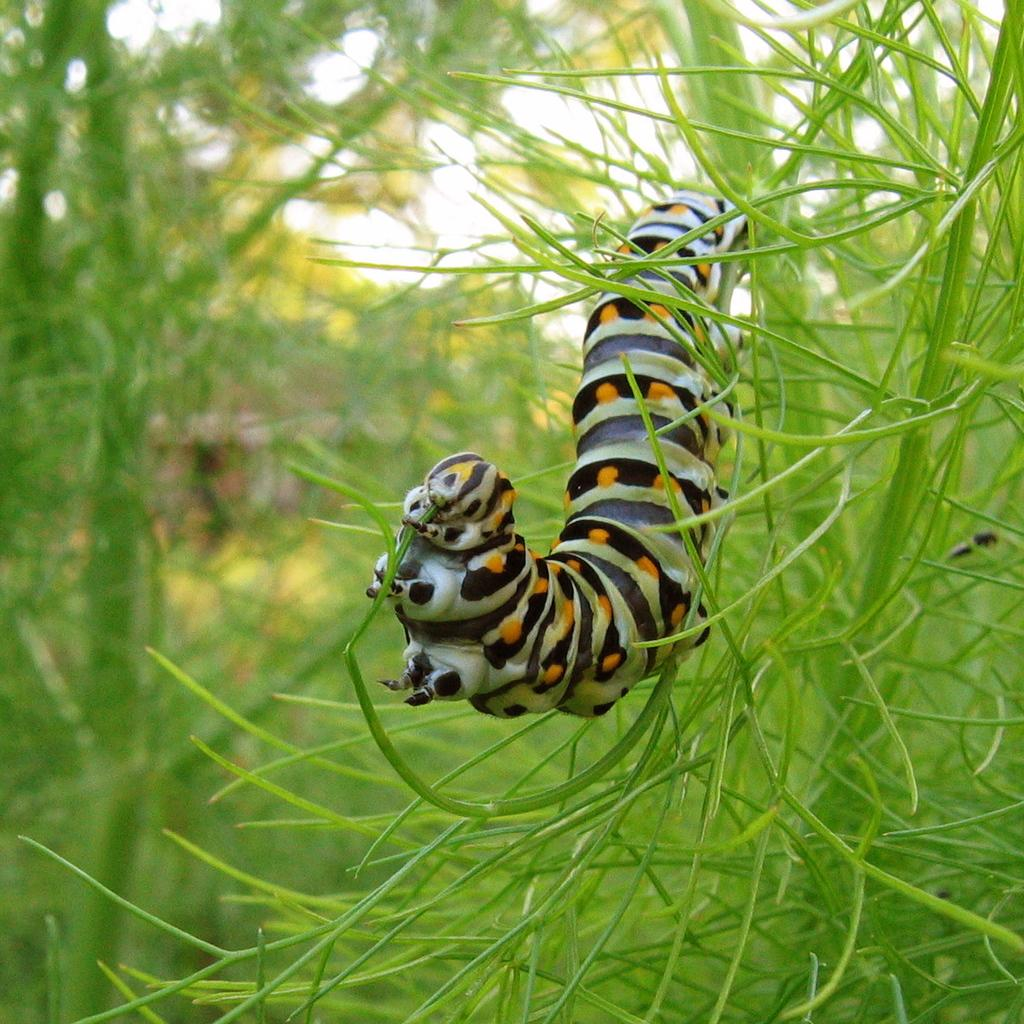What is present on the plant in the image? There is an insect on the plant in the image. What is the color of the plant? The plant is green. What can be seen in the background of the image? There is greenery in the background of the image. What type of guitar is the aunt playing in the image? There is no guitar or aunt present in the image; it features an insect on a green plant with greenery in the background. 